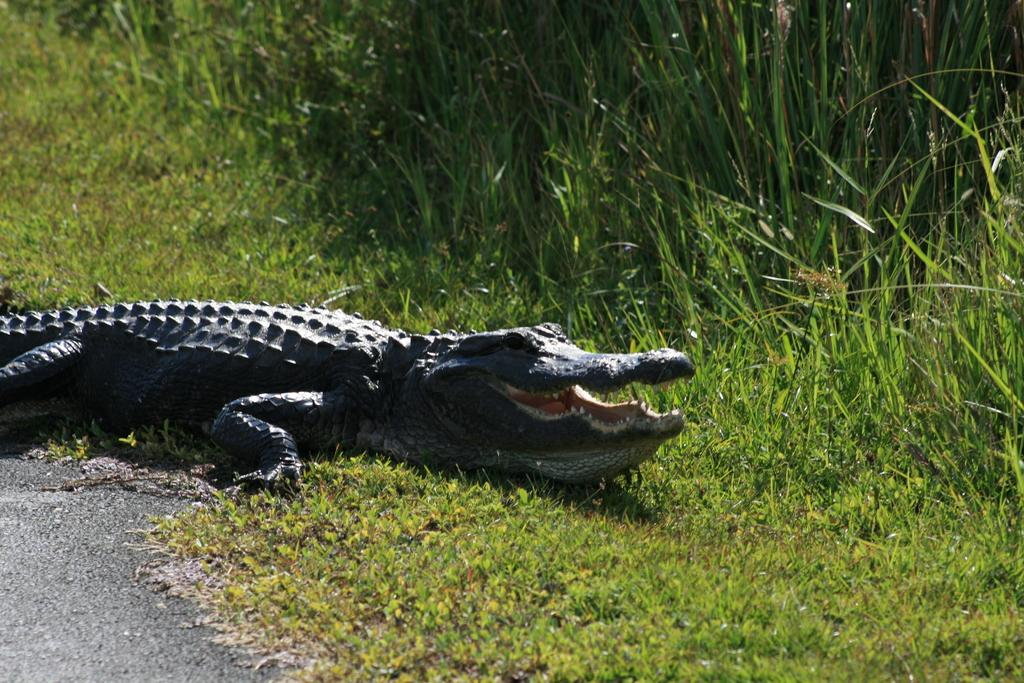What animal can be seen in the image? There is a crocodile in the image. What type of terrain is visible in the image? The ground is visible in the image. What type of vegetation is present in the image? There is grass and plants in the image. What type of apparel is the crocodile wearing in the image? The crocodile is not wearing any apparel in the image. What type of canvas is visible in the image? There is no canvas present in the image. 